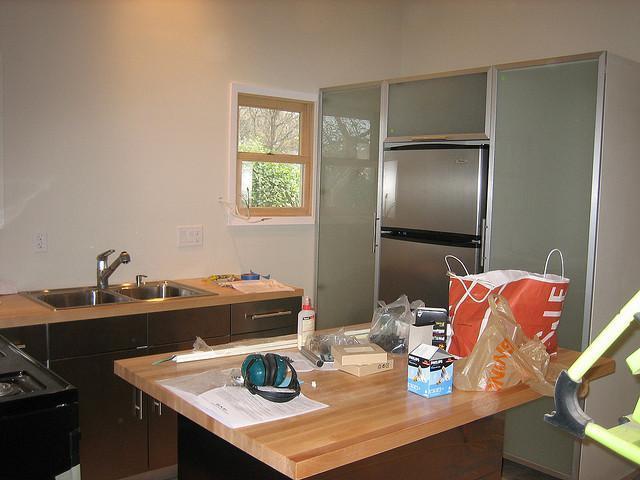How many people are wearing a green shirt?
Give a very brief answer. 0. 